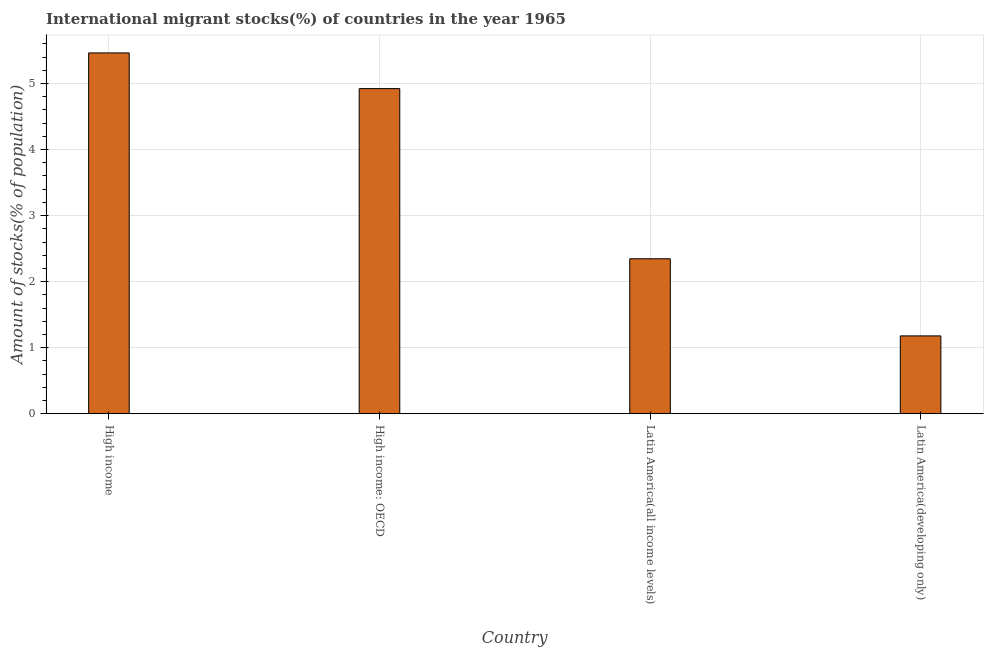What is the title of the graph?
Ensure brevity in your answer.  International migrant stocks(%) of countries in the year 1965. What is the label or title of the X-axis?
Your answer should be very brief. Country. What is the label or title of the Y-axis?
Make the answer very short. Amount of stocks(% of population). What is the number of international migrant stocks in High income?
Keep it short and to the point. 5.46. Across all countries, what is the maximum number of international migrant stocks?
Give a very brief answer. 5.46. Across all countries, what is the minimum number of international migrant stocks?
Your answer should be very brief. 1.18. In which country was the number of international migrant stocks minimum?
Ensure brevity in your answer.  Latin America(developing only). What is the sum of the number of international migrant stocks?
Your answer should be very brief. 13.91. What is the difference between the number of international migrant stocks in High income and High income: OECD?
Offer a terse response. 0.54. What is the average number of international migrant stocks per country?
Make the answer very short. 3.48. What is the median number of international migrant stocks?
Give a very brief answer. 3.63. What is the ratio of the number of international migrant stocks in High income: OECD to that in Latin America(developing only)?
Keep it short and to the point. 4.18. What is the difference between the highest and the second highest number of international migrant stocks?
Your answer should be compact. 0.54. Is the sum of the number of international migrant stocks in High income and Latin America(developing only) greater than the maximum number of international migrant stocks across all countries?
Your answer should be compact. Yes. What is the difference between the highest and the lowest number of international migrant stocks?
Your answer should be very brief. 4.28. In how many countries, is the number of international migrant stocks greater than the average number of international migrant stocks taken over all countries?
Give a very brief answer. 2. Are all the bars in the graph horizontal?
Provide a succinct answer. No. How many countries are there in the graph?
Ensure brevity in your answer.  4. Are the values on the major ticks of Y-axis written in scientific E-notation?
Offer a terse response. No. What is the Amount of stocks(% of population) in High income?
Ensure brevity in your answer.  5.46. What is the Amount of stocks(% of population) in High income: OECD?
Offer a terse response. 4.92. What is the Amount of stocks(% of population) of Latin America(all income levels)?
Provide a short and direct response. 2.35. What is the Amount of stocks(% of population) of Latin America(developing only)?
Give a very brief answer. 1.18. What is the difference between the Amount of stocks(% of population) in High income and High income: OECD?
Offer a terse response. 0.54. What is the difference between the Amount of stocks(% of population) in High income and Latin America(all income levels)?
Keep it short and to the point. 3.12. What is the difference between the Amount of stocks(% of population) in High income and Latin America(developing only)?
Your answer should be compact. 4.28. What is the difference between the Amount of stocks(% of population) in High income: OECD and Latin America(all income levels)?
Offer a terse response. 2.58. What is the difference between the Amount of stocks(% of population) in High income: OECD and Latin America(developing only)?
Ensure brevity in your answer.  3.74. What is the difference between the Amount of stocks(% of population) in Latin America(all income levels) and Latin America(developing only)?
Keep it short and to the point. 1.17. What is the ratio of the Amount of stocks(% of population) in High income to that in High income: OECD?
Keep it short and to the point. 1.11. What is the ratio of the Amount of stocks(% of population) in High income to that in Latin America(all income levels)?
Give a very brief answer. 2.33. What is the ratio of the Amount of stocks(% of population) in High income to that in Latin America(developing only)?
Offer a very short reply. 4.63. What is the ratio of the Amount of stocks(% of population) in High income: OECD to that in Latin America(all income levels)?
Your response must be concise. 2.1. What is the ratio of the Amount of stocks(% of population) in High income: OECD to that in Latin America(developing only)?
Offer a terse response. 4.18. What is the ratio of the Amount of stocks(% of population) in Latin America(all income levels) to that in Latin America(developing only)?
Your response must be concise. 1.99. 